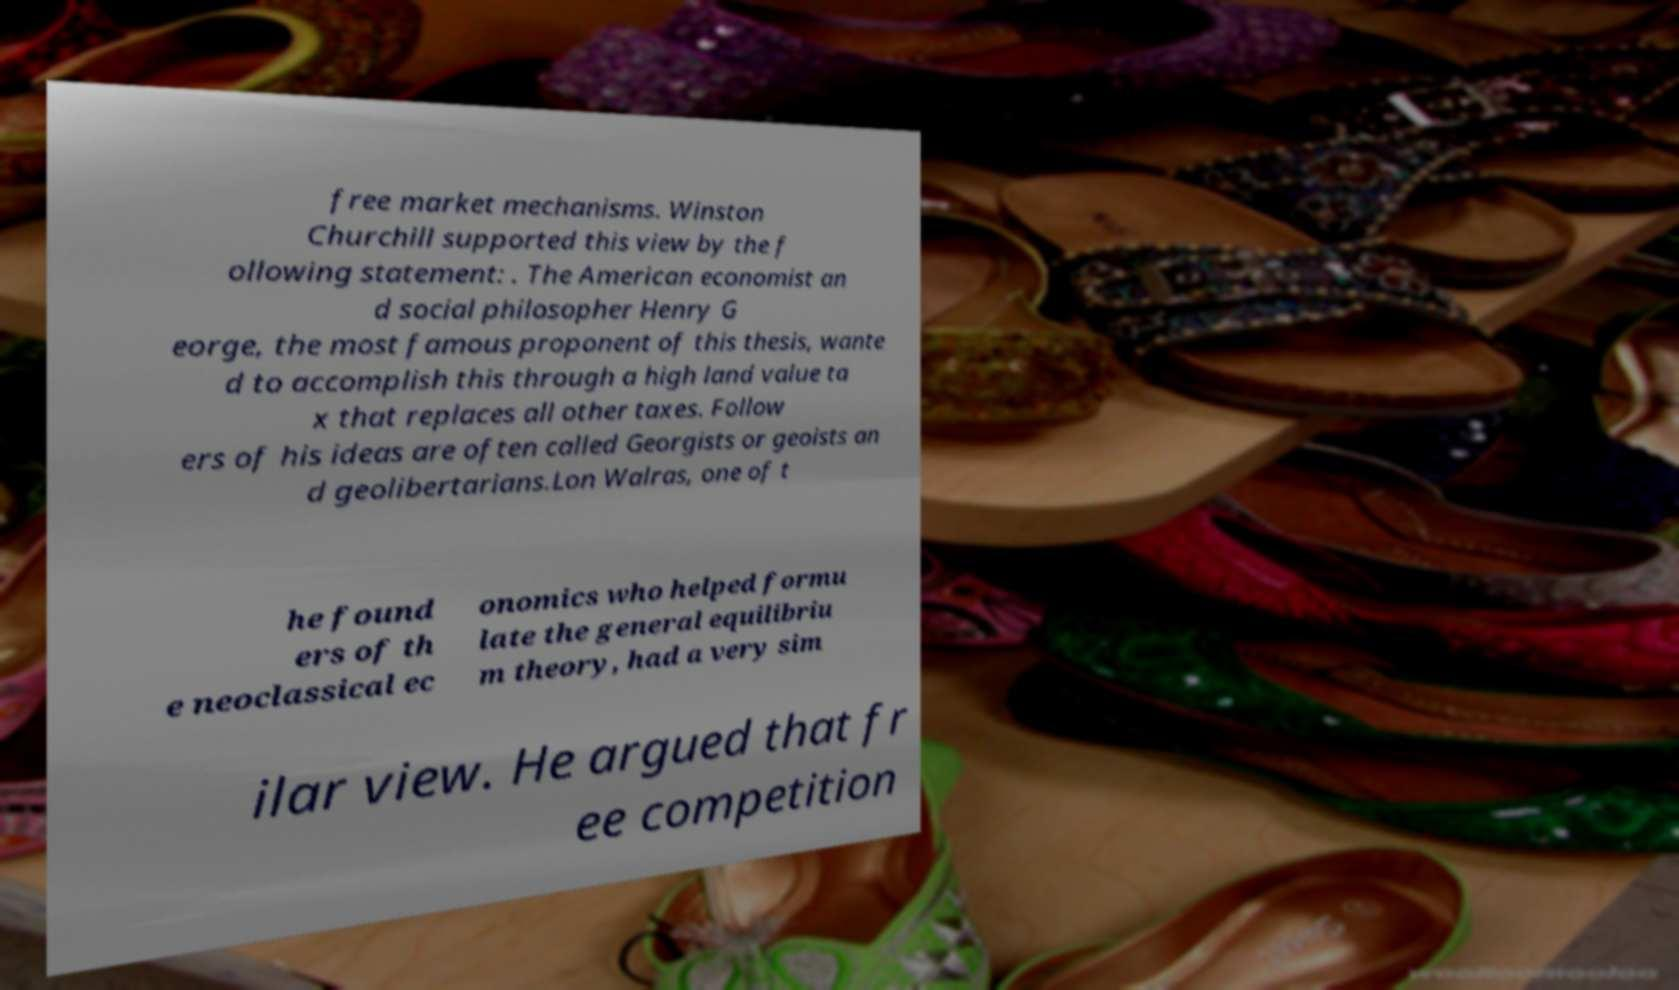I need the written content from this picture converted into text. Can you do that? free market mechanisms. Winston Churchill supported this view by the f ollowing statement: . The American economist an d social philosopher Henry G eorge, the most famous proponent of this thesis, wante d to accomplish this through a high land value ta x that replaces all other taxes. Follow ers of his ideas are often called Georgists or geoists an d geolibertarians.Lon Walras, one of t he found ers of th e neoclassical ec onomics who helped formu late the general equilibriu m theory, had a very sim ilar view. He argued that fr ee competition 